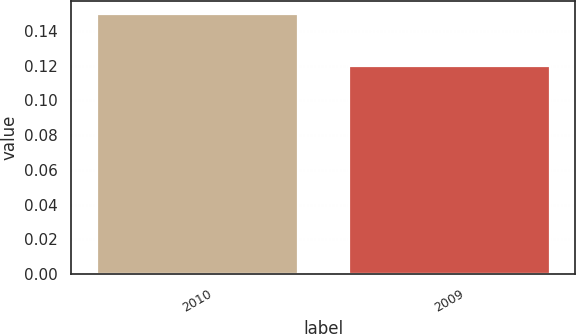Convert chart. <chart><loc_0><loc_0><loc_500><loc_500><bar_chart><fcel>2010<fcel>2009<nl><fcel>0.15<fcel>0.12<nl></chart> 